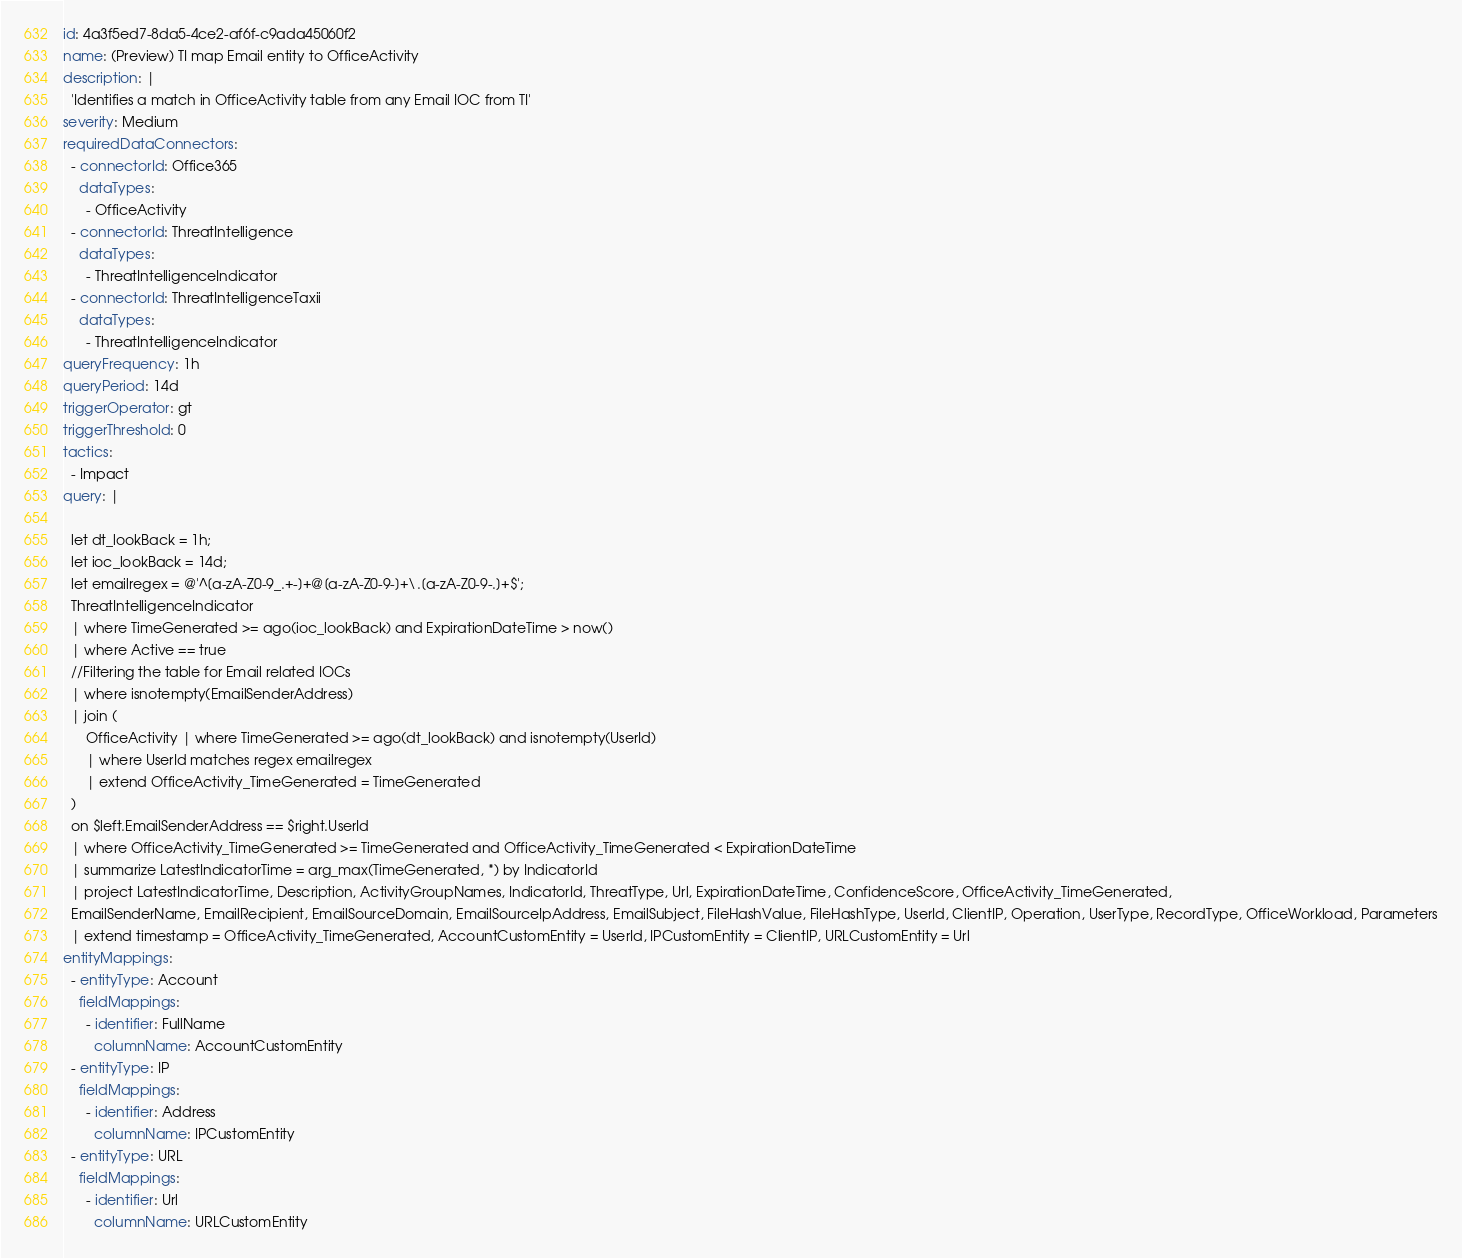<code> <loc_0><loc_0><loc_500><loc_500><_YAML_>id: 4a3f5ed7-8da5-4ce2-af6f-c9ada45060f2
name: (Preview) TI map Email entity to OfficeActivity
description: |
  'Identifies a match in OfficeActivity table from any Email IOC from TI'
severity: Medium
requiredDataConnectors:
  - connectorId: Office365
    dataTypes:
      - OfficeActivity
  - connectorId: ThreatIntelligence
    dataTypes:
      - ThreatIntelligenceIndicator
  - connectorId: ThreatIntelligenceTaxii
    dataTypes:
      - ThreatIntelligenceIndicator
queryFrequency: 1h
queryPeriod: 14d
triggerOperator: gt
triggerThreshold: 0
tactics:
  - Impact
query: |

  let dt_lookBack = 1h;
  let ioc_lookBack = 14d;
  let emailregex = @'^[a-zA-Z0-9_.+-]+@[a-zA-Z0-9-]+\.[a-zA-Z0-9-.]+$';
  ThreatIntelligenceIndicator
  | where TimeGenerated >= ago(ioc_lookBack) and ExpirationDateTime > now()
  | where Active == true
  //Filtering the table for Email related IOCs
  | where isnotempty(EmailSenderAddress)
  | join (
      OfficeActivity | where TimeGenerated >= ago(dt_lookBack) and isnotempty(UserId)
      | where UserId matches regex emailregex
      | extend OfficeActivity_TimeGenerated = TimeGenerated
  )
  on $left.EmailSenderAddress == $right.UserId
  | where OfficeActivity_TimeGenerated >= TimeGenerated and OfficeActivity_TimeGenerated < ExpirationDateTime
  | summarize LatestIndicatorTime = arg_max(TimeGenerated, *) by IndicatorId
  | project LatestIndicatorTime, Description, ActivityGroupNames, IndicatorId, ThreatType, Url, ExpirationDateTime, ConfidenceScore, OfficeActivity_TimeGenerated,
  EmailSenderName, EmailRecipient, EmailSourceDomain, EmailSourceIpAddress, EmailSubject, FileHashValue, FileHashType, UserId, ClientIP, Operation, UserType, RecordType, OfficeWorkload, Parameters
  | extend timestamp = OfficeActivity_TimeGenerated, AccountCustomEntity = UserId, IPCustomEntity = ClientIP, URLCustomEntity = Url
entityMappings:
  - entityType: Account
    fieldMappings:
      - identifier: FullName
        columnName: AccountCustomEntity
  - entityType: IP
    fieldMappings:
      - identifier: Address
        columnName: IPCustomEntity
  - entityType: URL
    fieldMappings:
      - identifier: Url
        columnName: URLCustomEntity
</code> 